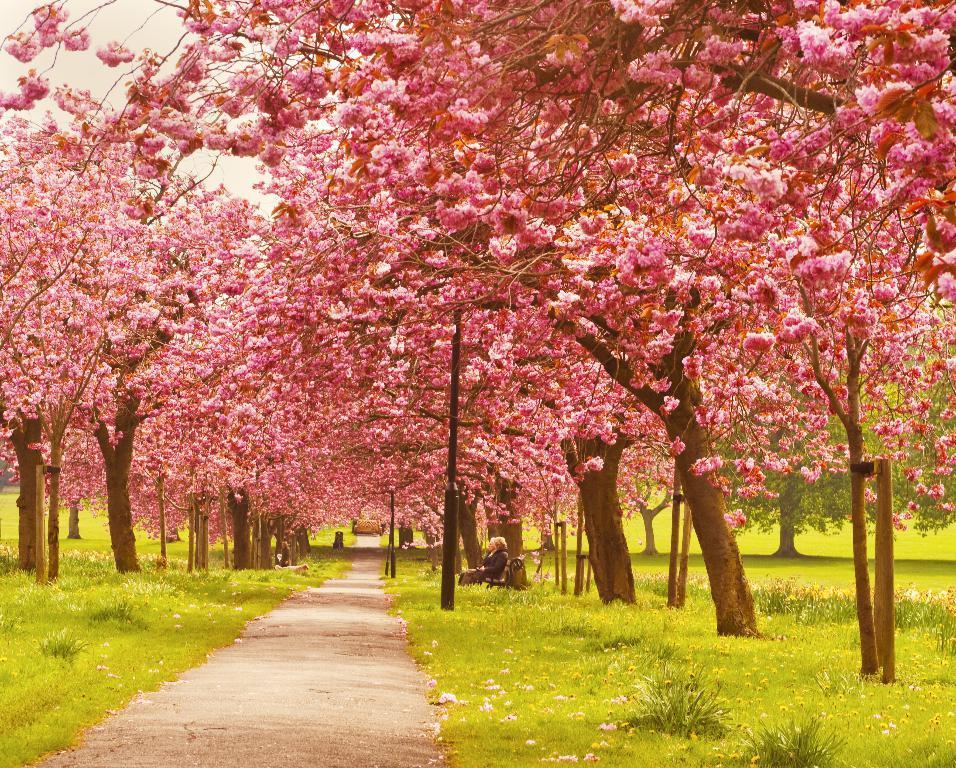Describe this image in one or two sentences. In this image there are trees, beneath the trees there is a lady sitting on a bench, in front of her there is a path. 